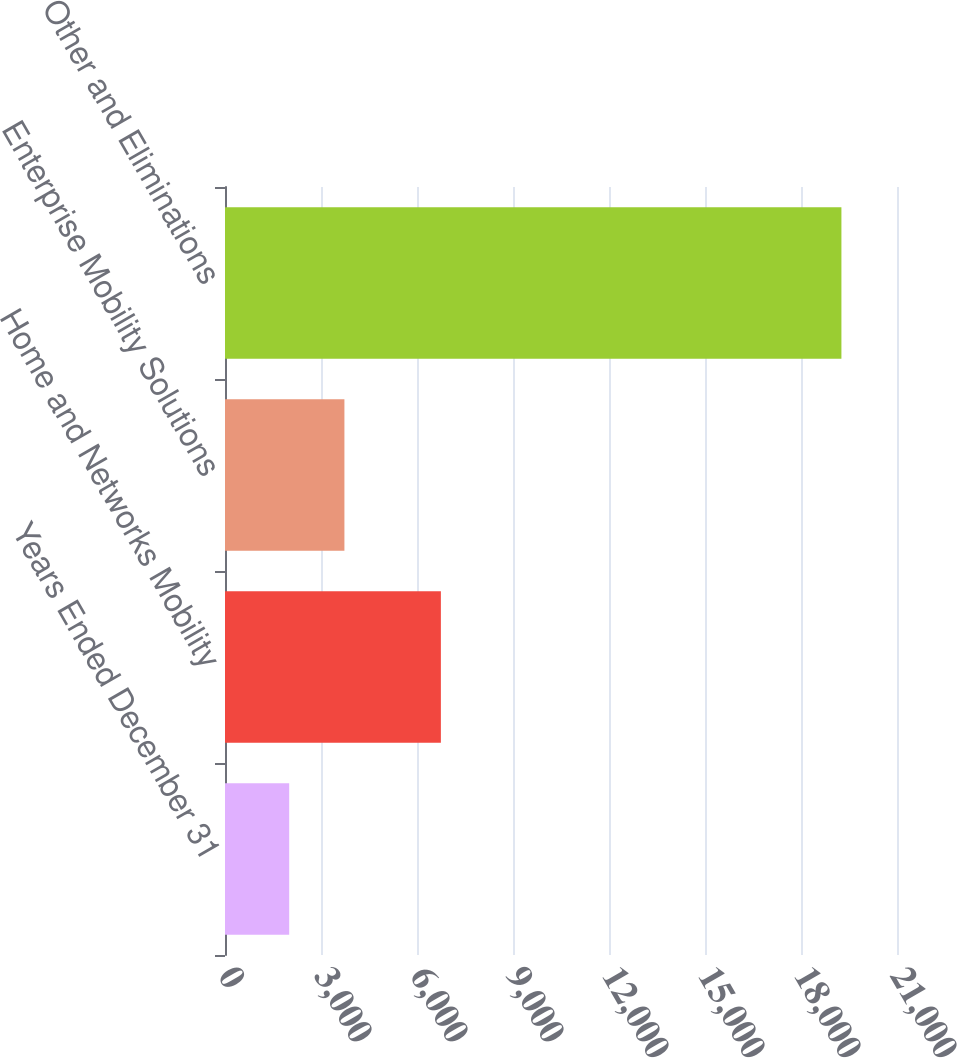<chart> <loc_0><loc_0><loc_500><loc_500><bar_chart><fcel>Years Ended December 31<fcel>Home and Networks Mobility<fcel>Enterprise Mobility Solutions<fcel>Other and Eliminations<nl><fcel>2006<fcel>6746<fcel>3731.7<fcel>19263<nl></chart> 